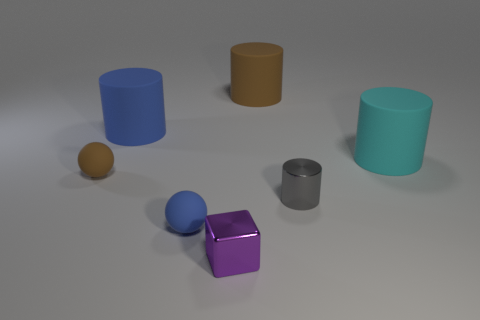Add 2 blue rubber spheres. How many objects exist? 9 Subtract all big brown cylinders. How many cylinders are left? 3 Subtract all blue spheres. How many spheres are left? 1 Subtract all cylinders. How many objects are left? 3 Subtract 2 balls. How many balls are left? 0 Subtract all large cylinders. Subtract all red matte cubes. How many objects are left? 4 Add 4 tiny gray cylinders. How many tiny gray cylinders are left? 5 Add 2 small gray objects. How many small gray objects exist? 3 Subtract 1 blue balls. How many objects are left? 6 Subtract all yellow cylinders. Subtract all blue balls. How many cylinders are left? 4 